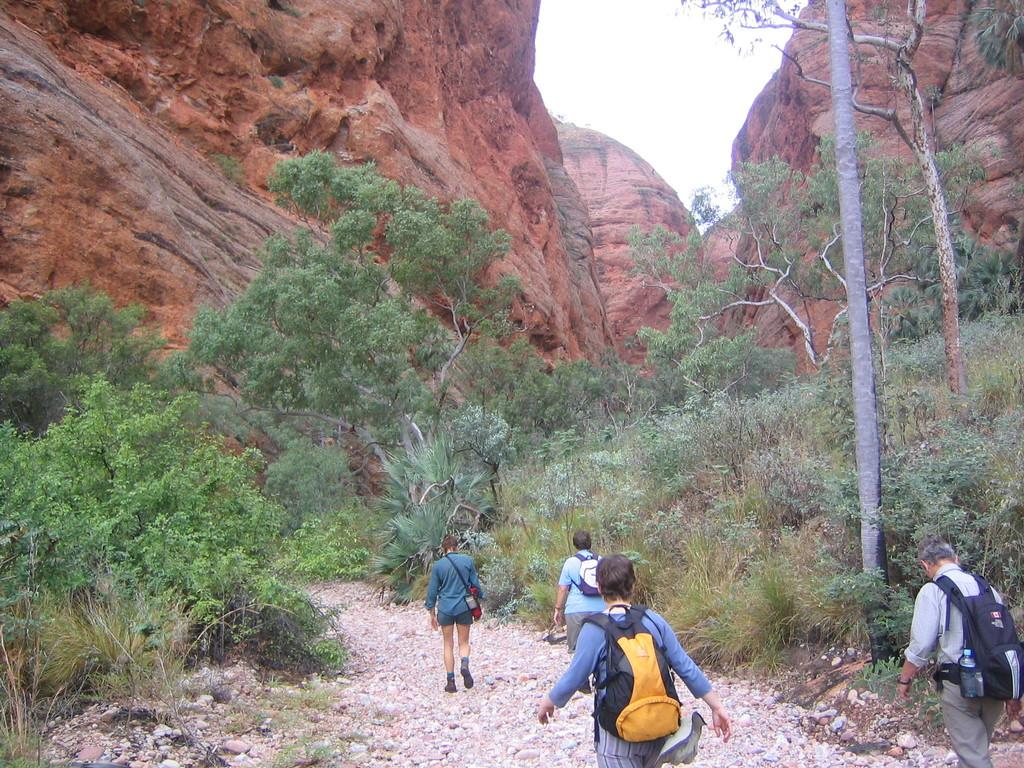How many people are in the image? There are four persons in the image. What are the people wearing? The people are wearing bags. What are the people doing in the image? The people are walking on a path. What can be seen on either side of the path? There are trees on either side of the path. What is visible in the background of the image? There is a mountain in the background of the image. What type of science experiment can be seen being conducted on a branch in the image? There is no science experiment or branch present in the image. What station are the people waiting at in the image? There is no station visible in the image; the people are walking on a path. 